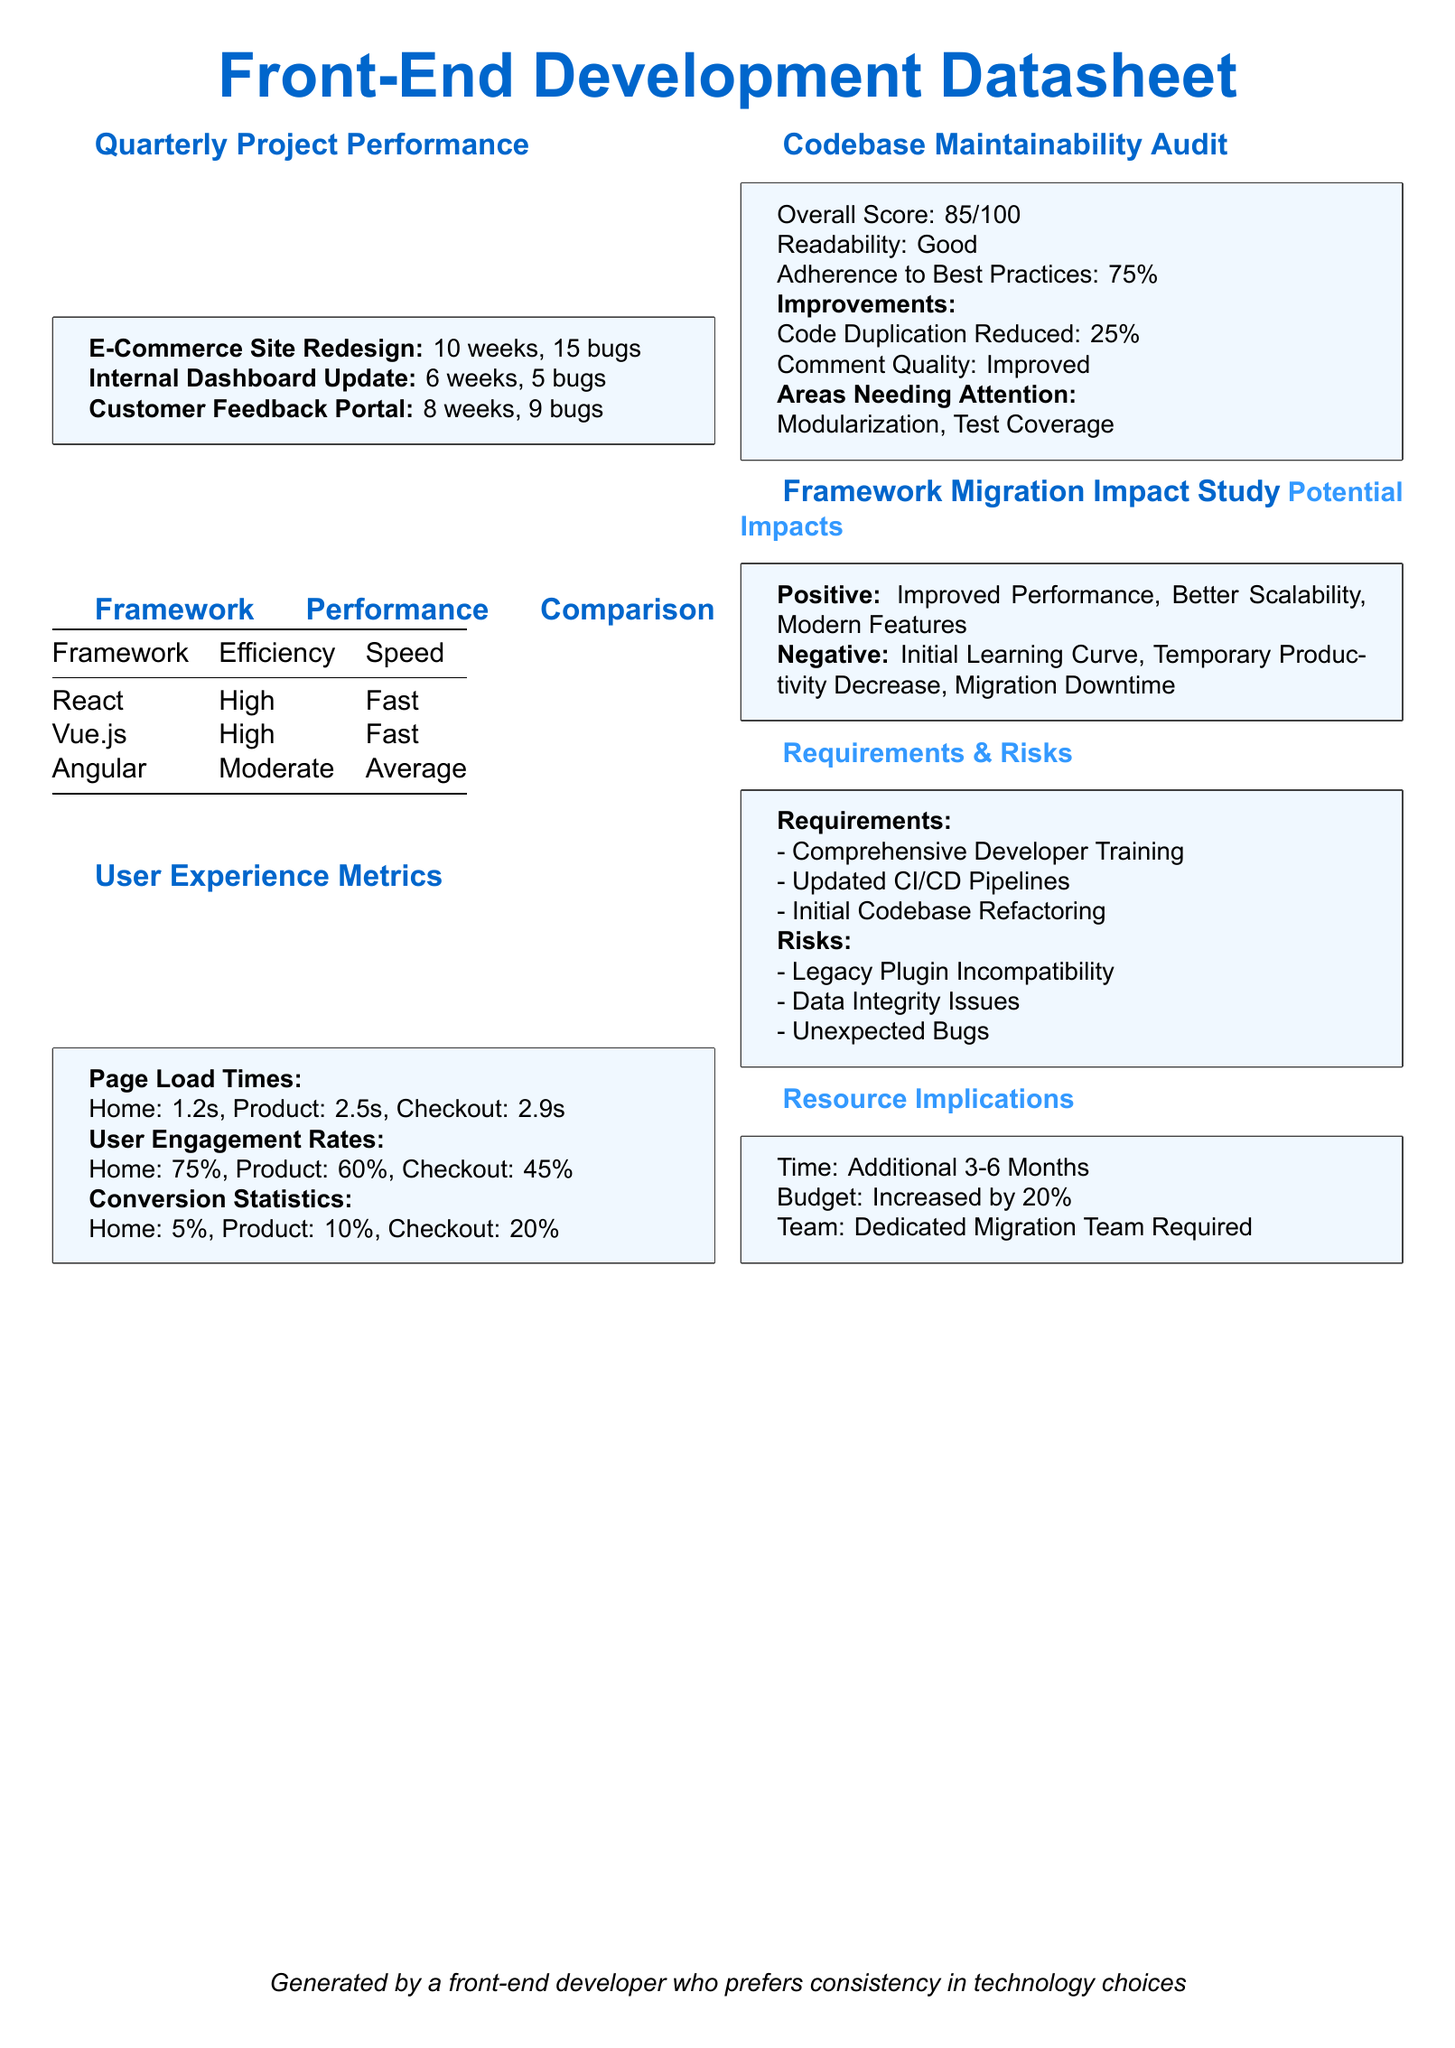What is the overall score of the codebase maintainability audit? The overall score is provided in the audit section of the document, indicating how maintainable the codebase is.
Answer: 85/100 How many weeks did the E-Commerce Site Redesign take? This information is listed under the quarterly project performance section, detailing the duration of the project.
Answer: 10 weeks What is the conversion statistic for the Checkout feature? This statistic is part of the user experience metrics, which breaks down conversion rates by feature.
Answer: 20% What are the two positive impacts of migrating to a new framework? These impacts are listed in the framework migration impact study section, highlighting potential benefits of migration.
Answer: Improved Performance, Better Scalability What percentage of best practices does the codebase adhere to? This percentage is mentioned in the maintainability audit section, evaluating how well the code follows best practices.
Answer: 75% Which framework has a moderate efficiency rating? This information can be found in the framework performance comparison table, denoting the efficiency of various frameworks.
Answer: Angular 